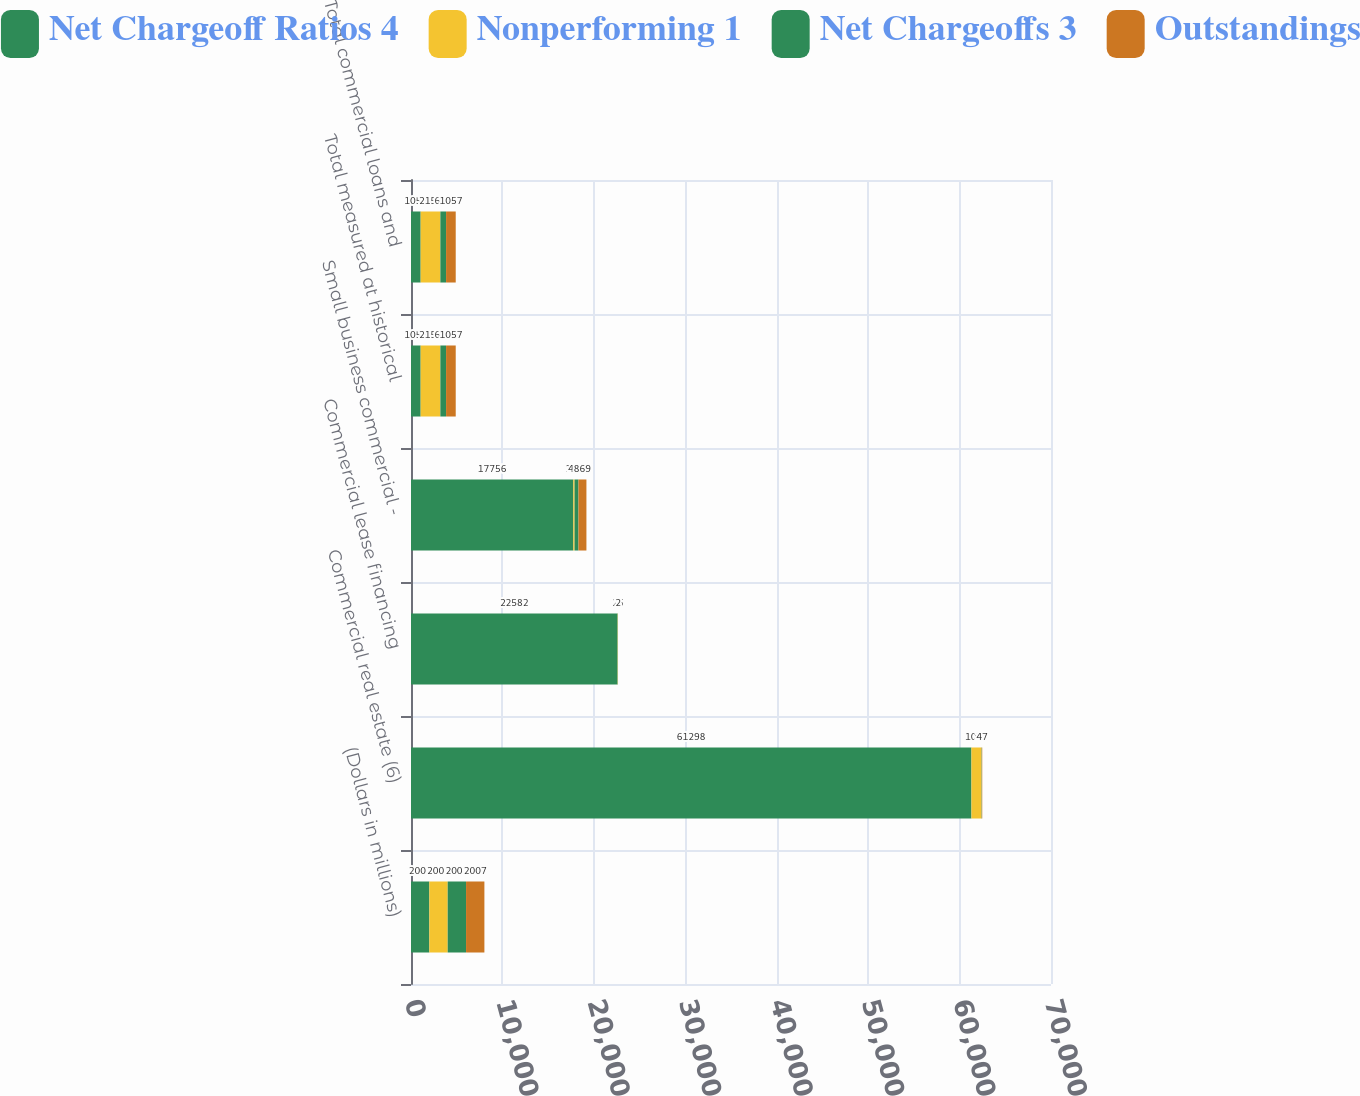Convert chart. <chart><loc_0><loc_0><loc_500><loc_500><stacked_bar_chart><ecel><fcel>(Dollars in millions)<fcel>Commercial real estate (6)<fcel>Commercial lease financing<fcel>Small business commercial -<fcel>Total measured at historical<fcel>Total commercial loans and<nl><fcel>Net Chargeoff Ratios 4<fcel>2007<fcel>61298<fcel>22582<fcel>17756<fcel>1057<fcel>1057<nl><fcel>Nonperforming 1<fcel>2007<fcel>1099<fcel>33<fcel>135<fcel>2155<fcel>2155<nl><fcel>Net Chargeoffs 3<fcel>2007<fcel>36<fcel>25<fcel>427<fcel>623<fcel>623<nl><fcel>Outstandings<fcel>2007<fcel>47<fcel>2<fcel>869<fcel>1057<fcel>1057<nl></chart> 